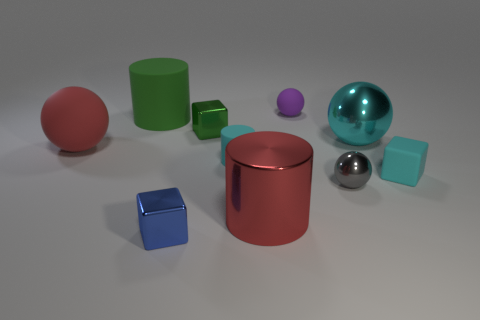Subtract all large green cylinders. How many cylinders are left? 2 Subtract 1 cylinders. How many cylinders are left? 2 Subtract all gray balls. How many balls are left? 3 Subtract all cylinders. How many objects are left? 7 Add 7 red shiny objects. How many red shiny objects are left? 8 Add 7 big red objects. How many big red objects exist? 9 Subtract 0 brown blocks. How many objects are left? 10 Subtract all purple blocks. Subtract all purple cylinders. How many blocks are left? 3 Subtract all small green metallic spheres. Subtract all tiny blue cubes. How many objects are left? 9 